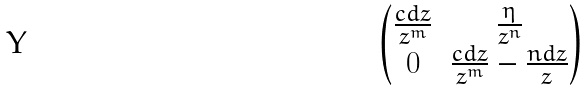Convert formula to latex. <formula><loc_0><loc_0><loc_500><loc_500>\begin{pmatrix} \frac { c d z } { z ^ { m } } & \frac { \eta } { z ^ { n } } \\ 0 & \frac { c d z } { z ^ { m } } - \frac { n d z } { z } \end{pmatrix}</formula> 